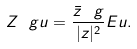Convert formula to latex. <formula><loc_0><loc_0><loc_500><loc_500>Z _ { \ } g u = \frac { \bar { z } ^ { \ } g } { | z | ^ { 2 } } E u .</formula> 